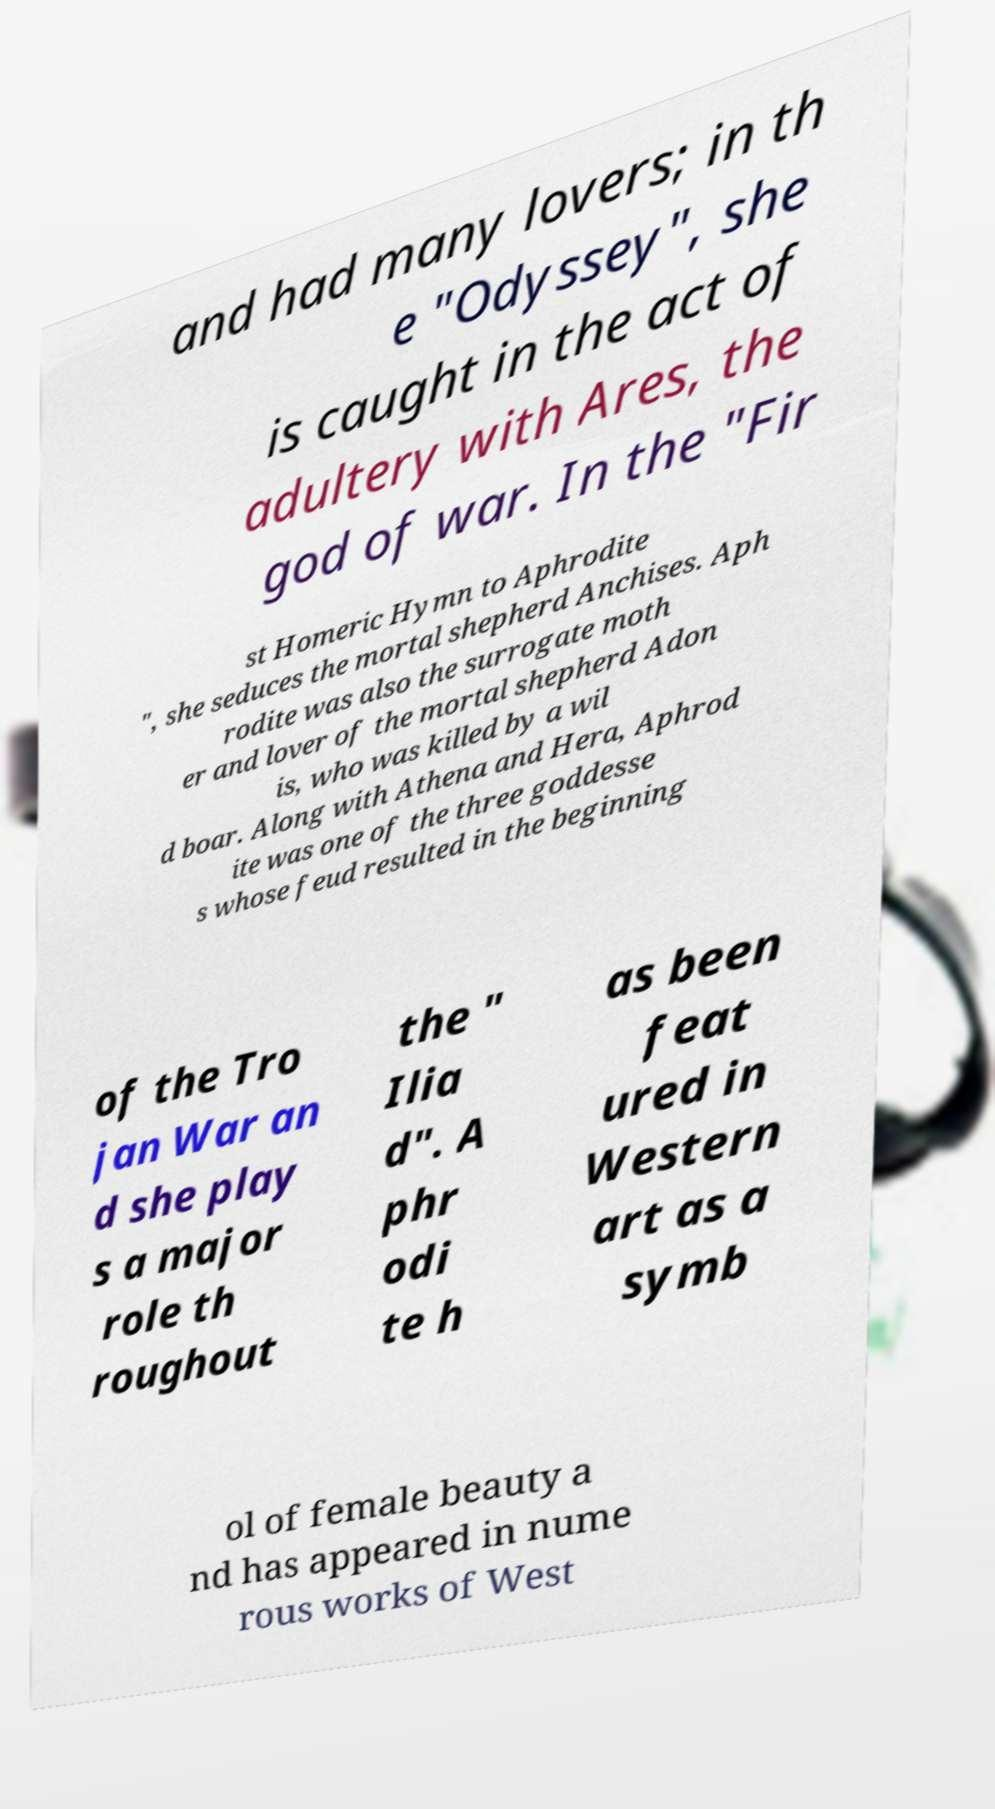Can you accurately transcribe the text from the provided image for me? and had many lovers; in th e "Odyssey", she is caught in the act of adultery with Ares, the god of war. In the "Fir st Homeric Hymn to Aphrodite ", she seduces the mortal shepherd Anchises. Aph rodite was also the surrogate moth er and lover of the mortal shepherd Adon is, who was killed by a wil d boar. Along with Athena and Hera, Aphrod ite was one of the three goddesse s whose feud resulted in the beginning of the Tro jan War an d she play s a major role th roughout the " Ilia d". A phr odi te h as been feat ured in Western art as a symb ol of female beauty a nd has appeared in nume rous works of West 